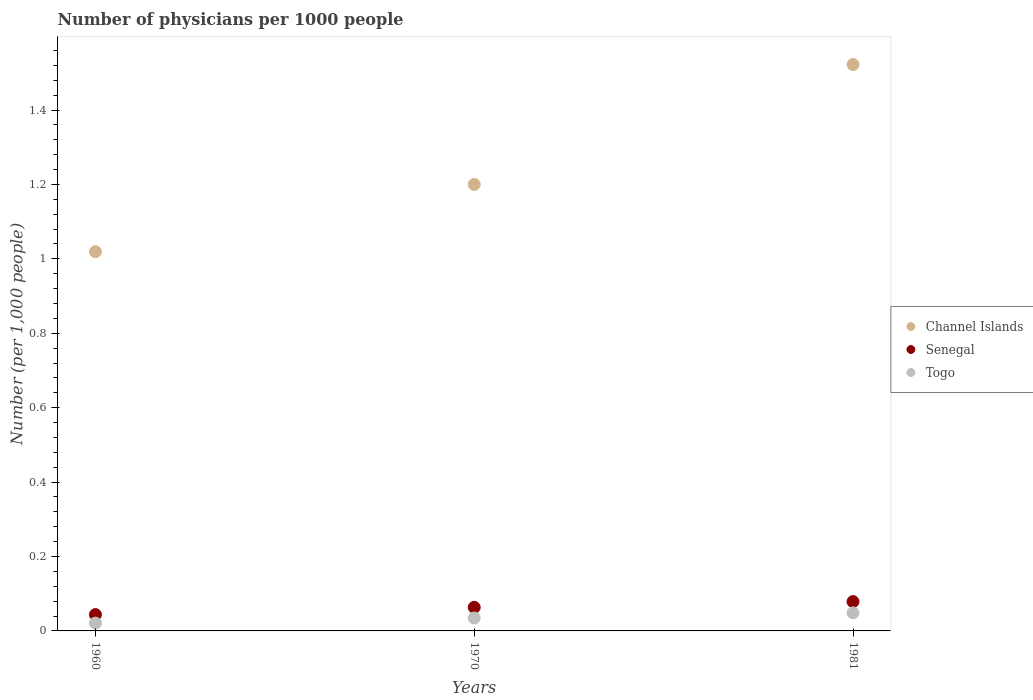How many different coloured dotlines are there?
Offer a terse response. 3. Is the number of dotlines equal to the number of legend labels?
Provide a short and direct response. Yes. What is the number of physicians in Senegal in 1960?
Your answer should be very brief. 0.04. Across all years, what is the maximum number of physicians in Togo?
Provide a succinct answer. 0.05. Across all years, what is the minimum number of physicians in Channel Islands?
Ensure brevity in your answer.  1.02. In which year was the number of physicians in Togo maximum?
Offer a terse response. 1981. In which year was the number of physicians in Senegal minimum?
Keep it short and to the point. 1960. What is the total number of physicians in Togo in the graph?
Your response must be concise. 0.1. What is the difference between the number of physicians in Channel Islands in 1960 and that in 1981?
Your response must be concise. -0.5. What is the difference between the number of physicians in Togo in 1960 and the number of physicians in Channel Islands in 1970?
Keep it short and to the point. -1.18. What is the average number of physicians in Senegal per year?
Make the answer very short. 0.06. In the year 1970, what is the difference between the number of physicians in Senegal and number of physicians in Togo?
Ensure brevity in your answer.  0.03. In how many years, is the number of physicians in Channel Islands greater than 0.6000000000000001?
Give a very brief answer. 3. What is the ratio of the number of physicians in Channel Islands in 1960 to that in 1981?
Give a very brief answer. 0.67. What is the difference between the highest and the second highest number of physicians in Channel Islands?
Your response must be concise. 0.32. What is the difference between the highest and the lowest number of physicians in Senegal?
Your response must be concise. 0.03. In how many years, is the number of physicians in Channel Islands greater than the average number of physicians in Channel Islands taken over all years?
Give a very brief answer. 1. Is it the case that in every year, the sum of the number of physicians in Senegal and number of physicians in Channel Islands  is greater than the number of physicians in Togo?
Provide a short and direct response. Yes. What is the difference between two consecutive major ticks on the Y-axis?
Keep it short and to the point. 0.2. Are the values on the major ticks of Y-axis written in scientific E-notation?
Provide a short and direct response. No. Where does the legend appear in the graph?
Give a very brief answer. Center right. How many legend labels are there?
Provide a short and direct response. 3. How are the legend labels stacked?
Ensure brevity in your answer.  Vertical. What is the title of the graph?
Provide a succinct answer. Number of physicians per 1000 people. Does "Lao PDR" appear as one of the legend labels in the graph?
Your answer should be compact. No. What is the label or title of the X-axis?
Ensure brevity in your answer.  Years. What is the label or title of the Y-axis?
Your answer should be compact. Number (per 1,0 people). What is the Number (per 1,000 people) of Channel Islands in 1960?
Your answer should be compact. 1.02. What is the Number (per 1,000 people) in Senegal in 1960?
Keep it short and to the point. 0.04. What is the Number (per 1,000 people) in Togo in 1960?
Offer a terse response. 0.02. What is the Number (per 1,000 people) of Channel Islands in 1970?
Make the answer very short. 1.2. What is the Number (per 1,000 people) of Senegal in 1970?
Keep it short and to the point. 0.06. What is the Number (per 1,000 people) of Togo in 1970?
Make the answer very short. 0.03. What is the Number (per 1,000 people) of Channel Islands in 1981?
Give a very brief answer. 1.52. What is the Number (per 1,000 people) of Senegal in 1981?
Provide a short and direct response. 0.08. What is the Number (per 1,000 people) of Togo in 1981?
Provide a succinct answer. 0.05. Across all years, what is the maximum Number (per 1,000 people) in Channel Islands?
Your answer should be compact. 1.52. Across all years, what is the maximum Number (per 1,000 people) of Senegal?
Your answer should be compact. 0.08. Across all years, what is the maximum Number (per 1,000 people) in Togo?
Give a very brief answer. 0.05. Across all years, what is the minimum Number (per 1,000 people) of Channel Islands?
Ensure brevity in your answer.  1.02. Across all years, what is the minimum Number (per 1,000 people) in Senegal?
Provide a short and direct response. 0.04. Across all years, what is the minimum Number (per 1,000 people) of Togo?
Provide a succinct answer. 0.02. What is the total Number (per 1,000 people) of Channel Islands in the graph?
Provide a short and direct response. 3.74. What is the total Number (per 1,000 people) of Senegal in the graph?
Provide a short and direct response. 0.19. What is the total Number (per 1,000 people) in Togo in the graph?
Your response must be concise. 0.1. What is the difference between the Number (per 1,000 people) of Channel Islands in 1960 and that in 1970?
Your answer should be compact. -0.18. What is the difference between the Number (per 1,000 people) of Senegal in 1960 and that in 1970?
Offer a terse response. -0.02. What is the difference between the Number (per 1,000 people) of Togo in 1960 and that in 1970?
Your answer should be very brief. -0.01. What is the difference between the Number (per 1,000 people) of Channel Islands in 1960 and that in 1981?
Your answer should be very brief. -0.5. What is the difference between the Number (per 1,000 people) of Senegal in 1960 and that in 1981?
Give a very brief answer. -0.03. What is the difference between the Number (per 1,000 people) in Togo in 1960 and that in 1981?
Offer a terse response. -0.03. What is the difference between the Number (per 1,000 people) of Channel Islands in 1970 and that in 1981?
Offer a terse response. -0.32. What is the difference between the Number (per 1,000 people) in Senegal in 1970 and that in 1981?
Provide a succinct answer. -0.02. What is the difference between the Number (per 1,000 people) in Togo in 1970 and that in 1981?
Give a very brief answer. -0.01. What is the difference between the Number (per 1,000 people) in Channel Islands in 1960 and the Number (per 1,000 people) in Senegal in 1970?
Provide a succinct answer. 0.96. What is the difference between the Number (per 1,000 people) of Channel Islands in 1960 and the Number (per 1,000 people) of Togo in 1970?
Give a very brief answer. 0.98. What is the difference between the Number (per 1,000 people) of Senegal in 1960 and the Number (per 1,000 people) of Togo in 1970?
Give a very brief answer. 0.01. What is the difference between the Number (per 1,000 people) in Channel Islands in 1960 and the Number (per 1,000 people) in Senegal in 1981?
Your response must be concise. 0.94. What is the difference between the Number (per 1,000 people) of Channel Islands in 1960 and the Number (per 1,000 people) of Togo in 1981?
Keep it short and to the point. 0.97. What is the difference between the Number (per 1,000 people) of Senegal in 1960 and the Number (per 1,000 people) of Togo in 1981?
Offer a very short reply. -0. What is the difference between the Number (per 1,000 people) in Channel Islands in 1970 and the Number (per 1,000 people) in Senegal in 1981?
Your answer should be compact. 1.12. What is the difference between the Number (per 1,000 people) of Channel Islands in 1970 and the Number (per 1,000 people) of Togo in 1981?
Provide a succinct answer. 1.15. What is the difference between the Number (per 1,000 people) of Senegal in 1970 and the Number (per 1,000 people) of Togo in 1981?
Your answer should be very brief. 0.01. What is the average Number (per 1,000 people) in Channel Islands per year?
Your answer should be very brief. 1.25. What is the average Number (per 1,000 people) of Senegal per year?
Keep it short and to the point. 0.06. What is the average Number (per 1,000 people) in Togo per year?
Your answer should be very brief. 0.03. In the year 1960, what is the difference between the Number (per 1,000 people) in Channel Islands and Number (per 1,000 people) in Senegal?
Your answer should be very brief. 0.98. In the year 1960, what is the difference between the Number (per 1,000 people) in Senegal and Number (per 1,000 people) in Togo?
Give a very brief answer. 0.02. In the year 1970, what is the difference between the Number (per 1,000 people) of Channel Islands and Number (per 1,000 people) of Senegal?
Your response must be concise. 1.14. In the year 1970, what is the difference between the Number (per 1,000 people) of Channel Islands and Number (per 1,000 people) of Togo?
Give a very brief answer. 1.17. In the year 1970, what is the difference between the Number (per 1,000 people) of Senegal and Number (per 1,000 people) of Togo?
Make the answer very short. 0.03. In the year 1981, what is the difference between the Number (per 1,000 people) in Channel Islands and Number (per 1,000 people) in Senegal?
Ensure brevity in your answer.  1.44. In the year 1981, what is the difference between the Number (per 1,000 people) in Channel Islands and Number (per 1,000 people) in Togo?
Keep it short and to the point. 1.47. In the year 1981, what is the difference between the Number (per 1,000 people) in Senegal and Number (per 1,000 people) in Togo?
Provide a short and direct response. 0.03. What is the ratio of the Number (per 1,000 people) of Channel Islands in 1960 to that in 1970?
Your answer should be compact. 0.85. What is the ratio of the Number (per 1,000 people) in Senegal in 1960 to that in 1970?
Provide a succinct answer. 0.69. What is the ratio of the Number (per 1,000 people) of Togo in 1960 to that in 1970?
Offer a terse response. 0.6. What is the ratio of the Number (per 1,000 people) of Channel Islands in 1960 to that in 1981?
Provide a short and direct response. 0.67. What is the ratio of the Number (per 1,000 people) of Senegal in 1960 to that in 1981?
Offer a very short reply. 0.56. What is the ratio of the Number (per 1,000 people) of Togo in 1960 to that in 1981?
Your response must be concise. 0.43. What is the ratio of the Number (per 1,000 people) in Channel Islands in 1970 to that in 1981?
Keep it short and to the point. 0.79. What is the ratio of the Number (per 1,000 people) of Senegal in 1970 to that in 1981?
Make the answer very short. 0.8. What is the ratio of the Number (per 1,000 people) in Togo in 1970 to that in 1981?
Provide a short and direct response. 0.72. What is the difference between the highest and the second highest Number (per 1,000 people) in Channel Islands?
Offer a very short reply. 0.32. What is the difference between the highest and the second highest Number (per 1,000 people) of Senegal?
Keep it short and to the point. 0.02. What is the difference between the highest and the second highest Number (per 1,000 people) of Togo?
Your response must be concise. 0.01. What is the difference between the highest and the lowest Number (per 1,000 people) in Channel Islands?
Ensure brevity in your answer.  0.5. What is the difference between the highest and the lowest Number (per 1,000 people) in Senegal?
Ensure brevity in your answer.  0.03. What is the difference between the highest and the lowest Number (per 1,000 people) in Togo?
Provide a succinct answer. 0.03. 